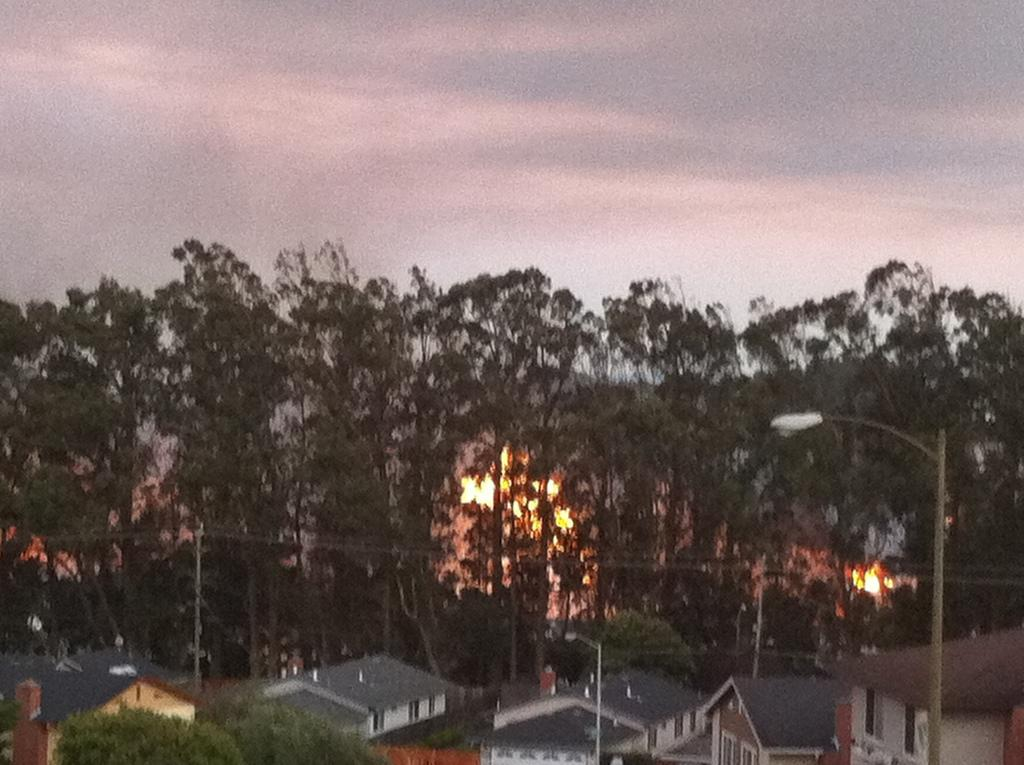What type of structures are in the foreground of the image? There is a group of buildings with roofs in the foreground of the image. What can be seen near the buildings in the foreground? Light poles are present in the foreground of the image. What is visible in the background of the image? There are poles with cables and a group of trees in the background of the image. How would you describe the sky in the image? The sky is cloudy in the background of the image. What type of scent can be detected coming from the bag in the image? There is no bag present in the image, so it is not possible to determine any scent. 